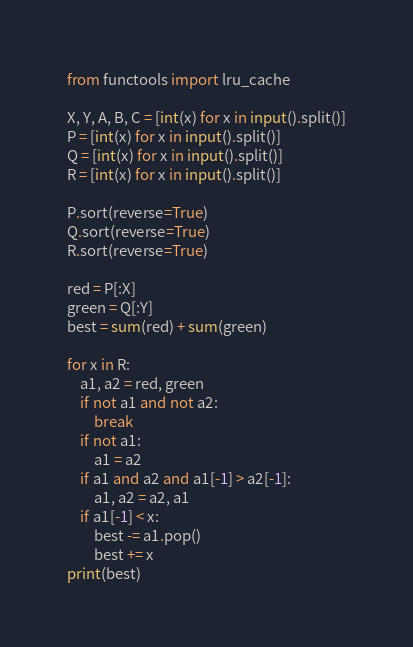Convert code to text. <code><loc_0><loc_0><loc_500><loc_500><_Python_>from functools import lru_cache

X, Y, A, B, C = [int(x) for x in input().split()]
P = [int(x) for x in input().split()]
Q = [int(x) for x in input().split()]
R = [int(x) for x in input().split()]

P.sort(reverse=True)
Q.sort(reverse=True)
R.sort(reverse=True)

red = P[:X]
green = Q[:Y]
best = sum(red) + sum(green)

for x in R:
    a1, a2 = red, green
    if not a1 and not a2:
        break
    if not a1:
        a1 = a2
    if a1 and a2 and a1[-1] > a2[-1]:
        a1, a2 = a2, a1
    if a1[-1] < x:
        best -= a1.pop()
        best += x
print(best)
</code> 